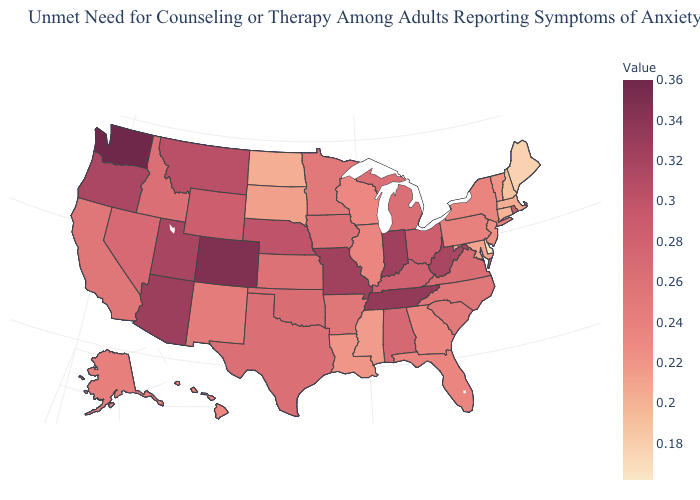Which states have the highest value in the USA?
Give a very brief answer. Washington. Does Ohio have a lower value than Kansas?
Concise answer only. No. Does Indiana have the highest value in the MidWest?
Write a very short answer. Yes. Which states have the lowest value in the South?
Answer briefly. Delaware. Among the states that border Tennessee , which have the lowest value?
Give a very brief answer. Mississippi. Which states have the highest value in the USA?
Keep it brief. Washington. Does Maryland have the highest value in the USA?
Concise answer only. No. Does Delaware have the lowest value in the USA?
Quick response, please. Yes. 